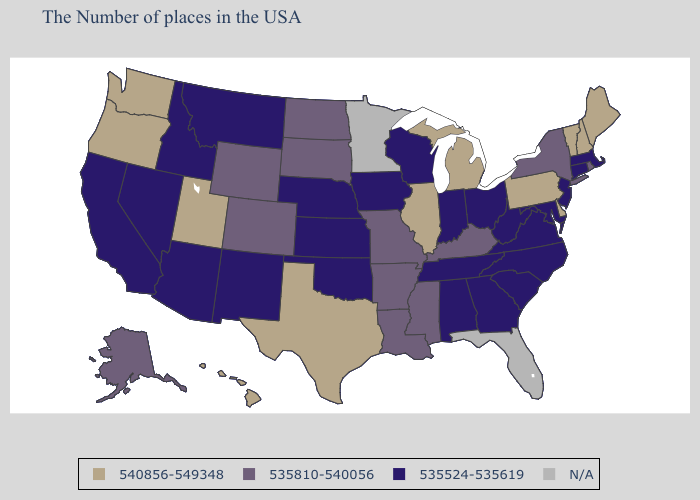What is the highest value in the Northeast ?
Keep it brief. 540856-549348. What is the lowest value in the West?
Write a very short answer. 535524-535619. Name the states that have a value in the range 535524-535619?
Answer briefly. Massachusetts, Connecticut, New Jersey, Maryland, Virginia, North Carolina, South Carolina, West Virginia, Ohio, Georgia, Indiana, Alabama, Tennessee, Wisconsin, Iowa, Kansas, Nebraska, Oklahoma, New Mexico, Montana, Arizona, Idaho, Nevada, California. Name the states that have a value in the range N/A?
Give a very brief answer. Florida, Minnesota. Does Hawaii have the highest value in the USA?
Answer briefly. Yes. How many symbols are there in the legend?
Answer briefly. 4. What is the value of Alabama?
Be succinct. 535524-535619. Name the states that have a value in the range 535524-535619?
Keep it brief. Massachusetts, Connecticut, New Jersey, Maryland, Virginia, North Carolina, South Carolina, West Virginia, Ohio, Georgia, Indiana, Alabama, Tennessee, Wisconsin, Iowa, Kansas, Nebraska, Oklahoma, New Mexico, Montana, Arizona, Idaho, Nevada, California. What is the value of New York?
Be succinct. 535810-540056. What is the value of Kansas?
Be succinct. 535524-535619. What is the value of Nevada?
Concise answer only. 535524-535619. Among the states that border North Dakota , which have the highest value?
Answer briefly. South Dakota. What is the lowest value in the USA?
Be succinct. 535524-535619. 